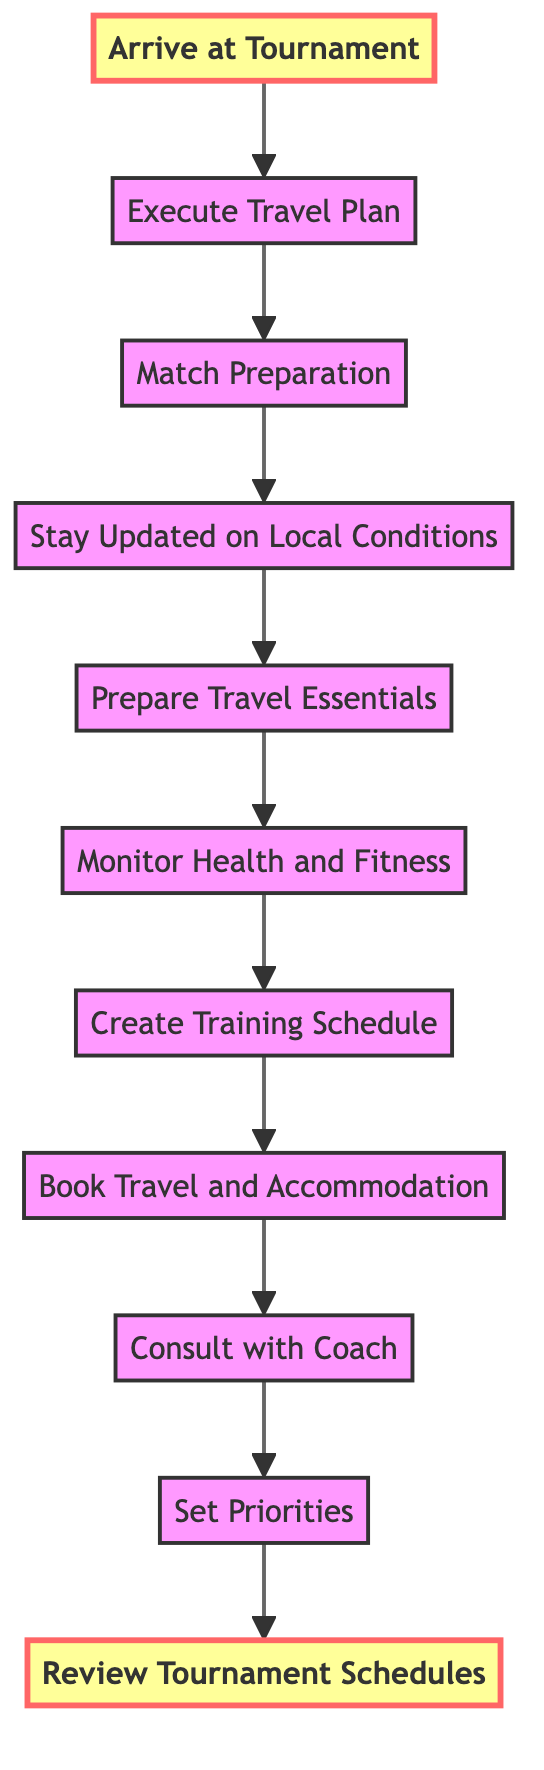What is the first step in the process? The first step indicated at the bottom of the diagram is "Arrive at Tournament." This step initiates the flow of actions required for managing match schedules efficiently.
Answer: Arrive at Tournament How many total steps are there in the flow chart? By counting the nodes from the diagram, we see there are 11 steps listed in the process that range from "Arrive at Tournament" to "Review Tournament Schedules."
Answer: 11 What comes immediately after "Execute Travel Plan"? The node that follows "Execute Travel Plan" is "Match Preparation." This indicates the sequence of actions taken once the travel plan is executed.
Answer: Match Preparation What action is taken right before "Create Training Schedule"? "Monitor Health and Fitness" is the action taken immediately prior to creating a training schedule. This shows the necessity of health monitoring to prepare for effective training.
Answer: Monitor Health and Fitness Which step involves discussing tournament choices? "Consult with Coach" is the step focused on discussing tournament choices and match strategies, highlighting its importance in the planning process.
Answer: Consult with Coach How does "Stay Updated on Local Conditions" relate to "Prepare Travel Essentials"? "Stay Updated on Local Conditions" precedes "Prepare Travel Essentials," suggesting that knowledge of local conditions is crucial before packing essential items for travel.
Answer: It precedes it What is the last step before arriving at the tournament? The last step before "Arrive at Tournament" is "Execute Travel Plan," indicating that successful travel execution is necessary to reach the tournament location.
Answer: Execute Travel Plan What is the purpose of "Set Priorities"? "Set Priorities" helps to determine which tournaments to participate in based on several factors like ranking points and surface preference, guiding strategic decision-making.
Answer: To determine tournament participation What is the significance of "Review Tournament Schedules"? "Review Tournament Schedules" is at the top of the flowchart, indicating it is the starting point that informs all subsequent decisions and strategies in managing travel and match schedules.
Answer: It informs subsequent decisions 